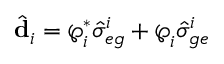Convert formula to latex. <formula><loc_0><loc_0><loc_500><loc_500>\hat { d } _ { i } = \wp _ { i } ^ { * } \hat { \sigma } _ { e g } ^ { i } + \wp _ { i } \hat { \sigma } _ { g e } ^ { i }</formula> 